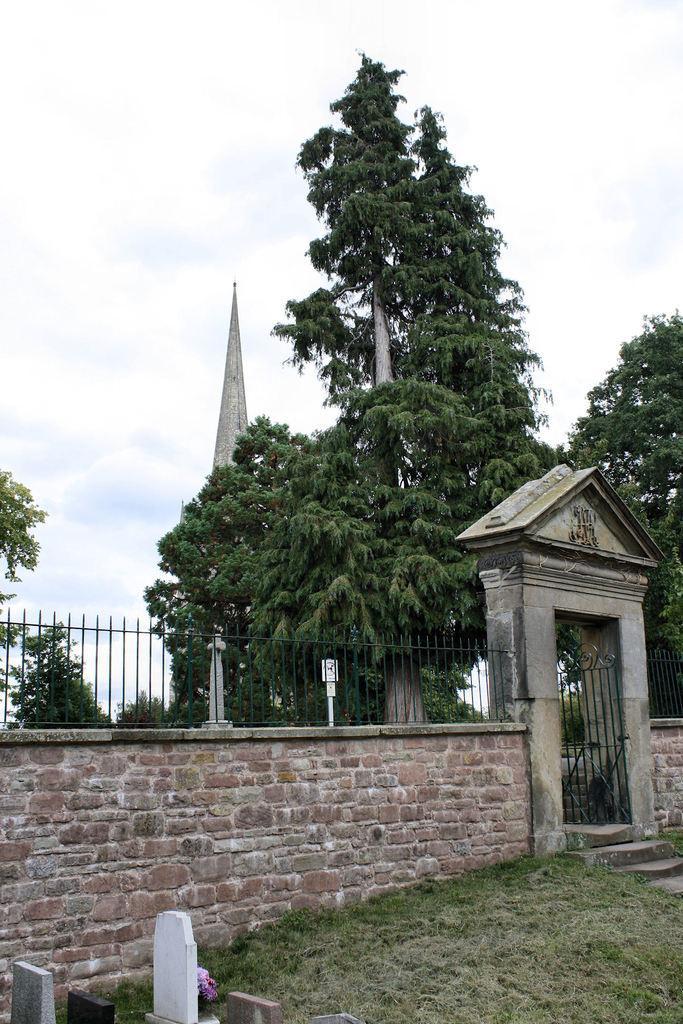Can you describe this image briefly? In this picture we can see a wall with the iron grilles. On the right side of the image, there is a gate. Behind the wall, there are trees, an architecture and the sky. At the bottom of the image, there are headstones and grass. 